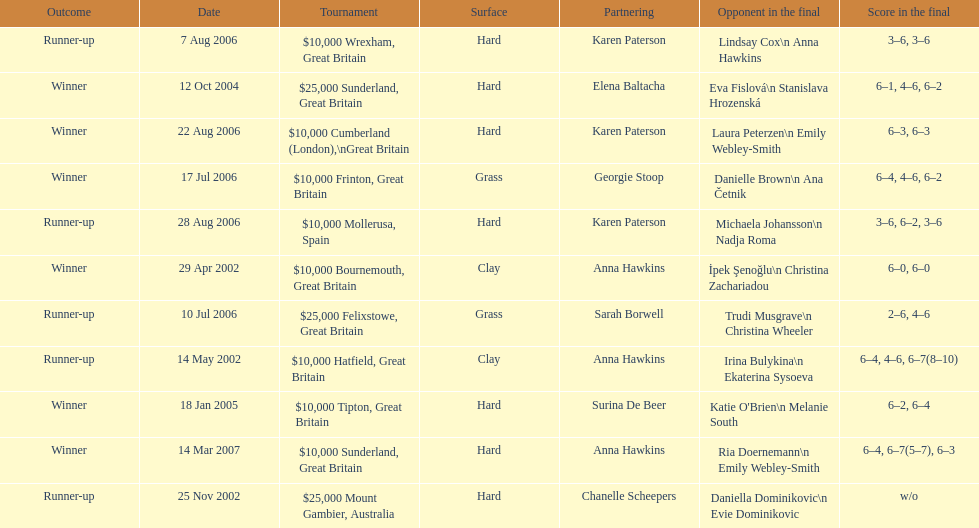How many were played on a hard surface? 7. Parse the table in full. {'header': ['Outcome', 'Date', 'Tournament', 'Surface', 'Partnering', 'Opponent in the final', 'Score in the final'], 'rows': [['Runner-up', '7 Aug 2006', '$10,000 Wrexham, Great Britain', 'Hard', 'Karen Paterson', 'Lindsay Cox\\n Anna Hawkins', '3–6, 3–6'], ['Winner', '12 Oct 2004', '$25,000 Sunderland, Great Britain', 'Hard', 'Elena Baltacha', 'Eva Fislová\\n Stanislava Hrozenská', '6–1, 4–6, 6–2'], ['Winner', '22 Aug 2006', '$10,000 Cumberland (London),\\nGreat Britain', 'Hard', 'Karen Paterson', 'Laura Peterzen\\n Emily Webley-Smith', '6–3, 6–3'], ['Winner', '17 Jul 2006', '$10,000 Frinton, Great Britain', 'Grass', 'Georgie Stoop', 'Danielle Brown\\n Ana Četnik', '6–4, 4–6, 6–2'], ['Runner-up', '28 Aug 2006', '$10,000 Mollerusa, Spain', 'Hard', 'Karen Paterson', 'Michaela Johansson\\n Nadja Roma', '3–6, 6–2, 3–6'], ['Winner', '29 Apr 2002', '$10,000 Bournemouth, Great Britain', 'Clay', 'Anna Hawkins', 'İpek Şenoğlu\\n Christina Zachariadou', '6–0, 6–0'], ['Runner-up', '10 Jul 2006', '$25,000 Felixstowe, Great Britain', 'Grass', 'Sarah Borwell', 'Trudi Musgrave\\n Christina Wheeler', '2–6, 4–6'], ['Runner-up', '14 May 2002', '$10,000 Hatfield, Great Britain', 'Clay', 'Anna Hawkins', 'Irina Bulykina\\n Ekaterina Sysoeva', '6–4, 4–6, 6–7(8–10)'], ['Winner', '18 Jan 2005', '$10,000 Tipton, Great Britain', 'Hard', 'Surina De Beer', "Katie O'Brien\\n Melanie South", '6–2, 6–4'], ['Winner', '14 Mar 2007', '$10,000 Sunderland, Great Britain', 'Hard', 'Anna Hawkins', 'Ria Doernemann\\n Emily Webley-Smith', '6–4, 6–7(5–7), 6–3'], ['Runner-up', '25 Nov 2002', '$25,000 Mount Gambier, Australia', 'Hard', 'Chanelle Scheepers', 'Daniella Dominikovic\\n Evie Dominikovic', 'w/o']]} 